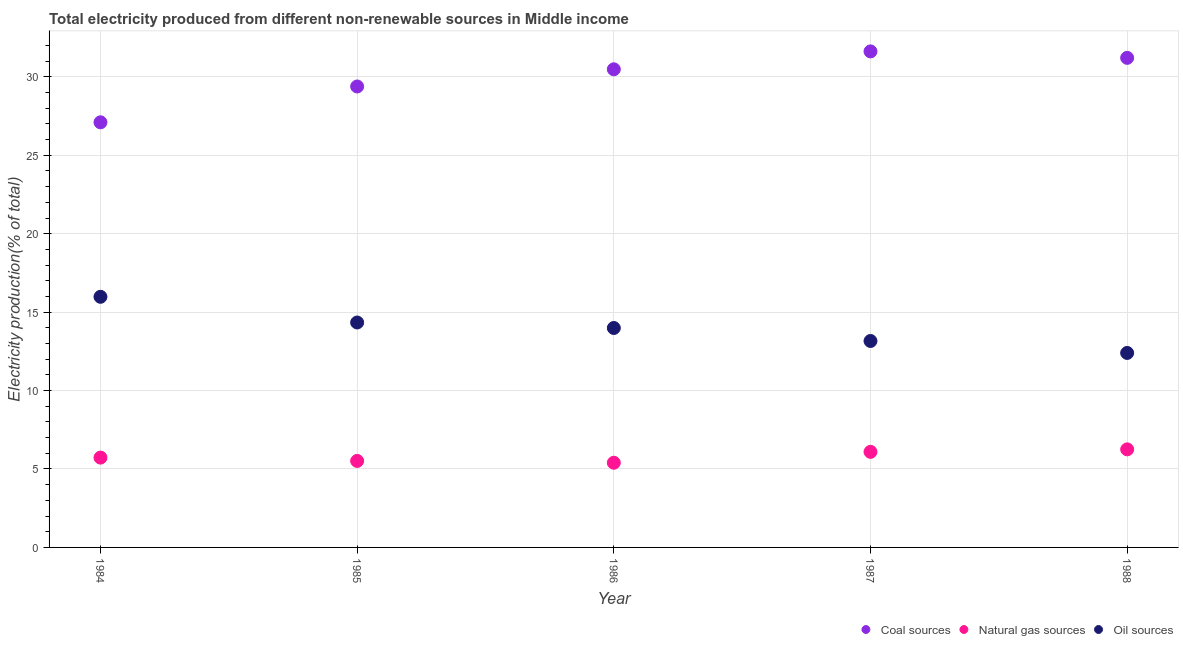Is the number of dotlines equal to the number of legend labels?
Make the answer very short. Yes. What is the percentage of electricity produced by natural gas in 1988?
Your answer should be compact. 6.25. Across all years, what is the maximum percentage of electricity produced by oil sources?
Offer a terse response. 15.98. Across all years, what is the minimum percentage of electricity produced by coal?
Keep it short and to the point. 27.1. What is the total percentage of electricity produced by natural gas in the graph?
Offer a very short reply. 28.98. What is the difference between the percentage of electricity produced by natural gas in 1986 and that in 1988?
Make the answer very short. -0.85. What is the difference between the percentage of electricity produced by natural gas in 1985 and the percentage of electricity produced by coal in 1984?
Your answer should be very brief. -21.59. What is the average percentage of electricity produced by natural gas per year?
Your answer should be compact. 5.8. In the year 1987, what is the difference between the percentage of electricity produced by natural gas and percentage of electricity produced by oil sources?
Your response must be concise. -7.07. In how many years, is the percentage of electricity produced by oil sources greater than 18 %?
Offer a very short reply. 0. What is the ratio of the percentage of electricity produced by natural gas in 1984 to that in 1985?
Provide a succinct answer. 1.04. Is the difference between the percentage of electricity produced by natural gas in 1986 and 1987 greater than the difference between the percentage of electricity produced by coal in 1986 and 1987?
Provide a succinct answer. Yes. What is the difference between the highest and the second highest percentage of electricity produced by natural gas?
Ensure brevity in your answer.  0.16. What is the difference between the highest and the lowest percentage of electricity produced by oil sources?
Make the answer very short. 3.58. In how many years, is the percentage of electricity produced by coal greater than the average percentage of electricity produced by coal taken over all years?
Keep it short and to the point. 3. How many dotlines are there?
Offer a very short reply. 3. What is the difference between two consecutive major ticks on the Y-axis?
Your answer should be compact. 5. Does the graph contain any zero values?
Your answer should be very brief. No. Where does the legend appear in the graph?
Give a very brief answer. Bottom right. How many legend labels are there?
Provide a short and direct response. 3. How are the legend labels stacked?
Offer a terse response. Horizontal. What is the title of the graph?
Ensure brevity in your answer.  Total electricity produced from different non-renewable sources in Middle income. What is the Electricity production(% of total) in Coal sources in 1984?
Ensure brevity in your answer.  27.1. What is the Electricity production(% of total) in Natural gas sources in 1984?
Make the answer very short. 5.73. What is the Electricity production(% of total) of Oil sources in 1984?
Your response must be concise. 15.98. What is the Electricity production(% of total) in Coal sources in 1985?
Keep it short and to the point. 29.39. What is the Electricity production(% of total) in Natural gas sources in 1985?
Keep it short and to the point. 5.52. What is the Electricity production(% of total) in Oil sources in 1985?
Ensure brevity in your answer.  14.34. What is the Electricity production(% of total) in Coal sources in 1986?
Your answer should be very brief. 30.48. What is the Electricity production(% of total) of Natural gas sources in 1986?
Your response must be concise. 5.4. What is the Electricity production(% of total) of Oil sources in 1986?
Offer a terse response. 13.99. What is the Electricity production(% of total) of Coal sources in 1987?
Your response must be concise. 31.62. What is the Electricity production(% of total) of Natural gas sources in 1987?
Keep it short and to the point. 6.09. What is the Electricity production(% of total) in Oil sources in 1987?
Give a very brief answer. 13.16. What is the Electricity production(% of total) in Coal sources in 1988?
Provide a short and direct response. 31.21. What is the Electricity production(% of total) of Natural gas sources in 1988?
Give a very brief answer. 6.25. What is the Electricity production(% of total) in Oil sources in 1988?
Your response must be concise. 12.4. Across all years, what is the maximum Electricity production(% of total) of Coal sources?
Ensure brevity in your answer.  31.62. Across all years, what is the maximum Electricity production(% of total) in Natural gas sources?
Ensure brevity in your answer.  6.25. Across all years, what is the maximum Electricity production(% of total) in Oil sources?
Offer a terse response. 15.98. Across all years, what is the minimum Electricity production(% of total) of Coal sources?
Your response must be concise. 27.1. Across all years, what is the minimum Electricity production(% of total) of Natural gas sources?
Your answer should be very brief. 5.4. Across all years, what is the minimum Electricity production(% of total) in Oil sources?
Offer a very short reply. 12.4. What is the total Electricity production(% of total) in Coal sources in the graph?
Give a very brief answer. 149.8. What is the total Electricity production(% of total) in Natural gas sources in the graph?
Provide a short and direct response. 28.98. What is the total Electricity production(% of total) in Oil sources in the graph?
Offer a very short reply. 69.86. What is the difference between the Electricity production(% of total) of Coal sources in 1984 and that in 1985?
Keep it short and to the point. -2.28. What is the difference between the Electricity production(% of total) of Natural gas sources in 1984 and that in 1985?
Keep it short and to the point. 0.21. What is the difference between the Electricity production(% of total) in Oil sources in 1984 and that in 1985?
Your answer should be very brief. 1.64. What is the difference between the Electricity production(% of total) in Coal sources in 1984 and that in 1986?
Keep it short and to the point. -3.38. What is the difference between the Electricity production(% of total) in Natural gas sources in 1984 and that in 1986?
Ensure brevity in your answer.  0.33. What is the difference between the Electricity production(% of total) in Oil sources in 1984 and that in 1986?
Offer a terse response. 1.99. What is the difference between the Electricity production(% of total) in Coal sources in 1984 and that in 1987?
Make the answer very short. -4.52. What is the difference between the Electricity production(% of total) in Natural gas sources in 1984 and that in 1987?
Offer a terse response. -0.37. What is the difference between the Electricity production(% of total) of Oil sources in 1984 and that in 1987?
Your response must be concise. 2.82. What is the difference between the Electricity production(% of total) in Coal sources in 1984 and that in 1988?
Offer a terse response. -4.11. What is the difference between the Electricity production(% of total) of Natural gas sources in 1984 and that in 1988?
Your response must be concise. -0.53. What is the difference between the Electricity production(% of total) of Oil sources in 1984 and that in 1988?
Make the answer very short. 3.58. What is the difference between the Electricity production(% of total) in Coal sources in 1985 and that in 1986?
Offer a very short reply. -1.09. What is the difference between the Electricity production(% of total) in Natural gas sources in 1985 and that in 1986?
Give a very brief answer. 0.12. What is the difference between the Electricity production(% of total) of Oil sources in 1985 and that in 1986?
Offer a terse response. 0.35. What is the difference between the Electricity production(% of total) in Coal sources in 1985 and that in 1987?
Offer a very short reply. -2.24. What is the difference between the Electricity production(% of total) in Natural gas sources in 1985 and that in 1987?
Provide a short and direct response. -0.58. What is the difference between the Electricity production(% of total) of Oil sources in 1985 and that in 1987?
Ensure brevity in your answer.  1.18. What is the difference between the Electricity production(% of total) of Coal sources in 1985 and that in 1988?
Make the answer very short. -1.83. What is the difference between the Electricity production(% of total) in Natural gas sources in 1985 and that in 1988?
Ensure brevity in your answer.  -0.74. What is the difference between the Electricity production(% of total) in Oil sources in 1985 and that in 1988?
Your answer should be compact. 1.94. What is the difference between the Electricity production(% of total) in Coal sources in 1986 and that in 1987?
Make the answer very short. -1.14. What is the difference between the Electricity production(% of total) in Natural gas sources in 1986 and that in 1987?
Keep it short and to the point. -0.69. What is the difference between the Electricity production(% of total) of Oil sources in 1986 and that in 1987?
Offer a very short reply. 0.83. What is the difference between the Electricity production(% of total) of Coal sources in 1986 and that in 1988?
Your answer should be very brief. -0.73. What is the difference between the Electricity production(% of total) of Natural gas sources in 1986 and that in 1988?
Your answer should be compact. -0.85. What is the difference between the Electricity production(% of total) in Oil sources in 1986 and that in 1988?
Your answer should be compact. 1.59. What is the difference between the Electricity production(% of total) of Coal sources in 1987 and that in 1988?
Your response must be concise. 0.41. What is the difference between the Electricity production(% of total) of Natural gas sources in 1987 and that in 1988?
Provide a succinct answer. -0.16. What is the difference between the Electricity production(% of total) of Oil sources in 1987 and that in 1988?
Your answer should be compact. 0.76. What is the difference between the Electricity production(% of total) in Coal sources in 1984 and the Electricity production(% of total) in Natural gas sources in 1985?
Give a very brief answer. 21.59. What is the difference between the Electricity production(% of total) in Coal sources in 1984 and the Electricity production(% of total) in Oil sources in 1985?
Offer a very short reply. 12.76. What is the difference between the Electricity production(% of total) in Natural gas sources in 1984 and the Electricity production(% of total) in Oil sources in 1985?
Keep it short and to the point. -8.61. What is the difference between the Electricity production(% of total) of Coal sources in 1984 and the Electricity production(% of total) of Natural gas sources in 1986?
Provide a succinct answer. 21.7. What is the difference between the Electricity production(% of total) in Coal sources in 1984 and the Electricity production(% of total) in Oil sources in 1986?
Your response must be concise. 13.11. What is the difference between the Electricity production(% of total) in Natural gas sources in 1984 and the Electricity production(% of total) in Oil sources in 1986?
Offer a very short reply. -8.26. What is the difference between the Electricity production(% of total) in Coal sources in 1984 and the Electricity production(% of total) in Natural gas sources in 1987?
Offer a terse response. 21.01. What is the difference between the Electricity production(% of total) of Coal sources in 1984 and the Electricity production(% of total) of Oil sources in 1987?
Keep it short and to the point. 13.94. What is the difference between the Electricity production(% of total) in Natural gas sources in 1984 and the Electricity production(% of total) in Oil sources in 1987?
Your answer should be compact. -7.43. What is the difference between the Electricity production(% of total) of Coal sources in 1984 and the Electricity production(% of total) of Natural gas sources in 1988?
Your answer should be very brief. 20.85. What is the difference between the Electricity production(% of total) in Coal sources in 1984 and the Electricity production(% of total) in Oil sources in 1988?
Offer a very short reply. 14.7. What is the difference between the Electricity production(% of total) in Natural gas sources in 1984 and the Electricity production(% of total) in Oil sources in 1988?
Offer a very short reply. -6.67. What is the difference between the Electricity production(% of total) in Coal sources in 1985 and the Electricity production(% of total) in Natural gas sources in 1986?
Provide a succinct answer. 23.99. What is the difference between the Electricity production(% of total) of Coal sources in 1985 and the Electricity production(% of total) of Oil sources in 1986?
Provide a short and direct response. 15.4. What is the difference between the Electricity production(% of total) of Natural gas sources in 1985 and the Electricity production(% of total) of Oil sources in 1986?
Your answer should be compact. -8.47. What is the difference between the Electricity production(% of total) in Coal sources in 1985 and the Electricity production(% of total) in Natural gas sources in 1987?
Your answer should be compact. 23.29. What is the difference between the Electricity production(% of total) in Coal sources in 1985 and the Electricity production(% of total) in Oil sources in 1987?
Your answer should be very brief. 16.23. What is the difference between the Electricity production(% of total) of Natural gas sources in 1985 and the Electricity production(% of total) of Oil sources in 1987?
Give a very brief answer. -7.65. What is the difference between the Electricity production(% of total) in Coal sources in 1985 and the Electricity production(% of total) in Natural gas sources in 1988?
Make the answer very short. 23.13. What is the difference between the Electricity production(% of total) of Coal sources in 1985 and the Electricity production(% of total) of Oil sources in 1988?
Ensure brevity in your answer.  16.99. What is the difference between the Electricity production(% of total) of Natural gas sources in 1985 and the Electricity production(% of total) of Oil sources in 1988?
Provide a short and direct response. -6.88. What is the difference between the Electricity production(% of total) in Coal sources in 1986 and the Electricity production(% of total) in Natural gas sources in 1987?
Provide a succinct answer. 24.39. What is the difference between the Electricity production(% of total) in Coal sources in 1986 and the Electricity production(% of total) in Oil sources in 1987?
Ensure brevity in your answer.  17.32. What is the difference between the Electricity production(% of total) in Natural gas sources in 1986 and the Electricity production(% of total) in Oil sources in 1987?
Ensure brevity in your answer.  -7.76. What is the difference between the Electricity production(% of total) of Coal sources in 1986 and the Electricity production(% of total) of Natural gas sources in 1988?
Your response must be concise. 24.23. What is the difference between the Electricity production(% of total) of Coal sources in 1986 and the Electricity production(% of total) of Oil sources in 1988?
Make the answer very short. 18.08. What is the difference between the Electricity production(% of total) of Natural gas sources in 1986 and the Electricity production(% of total) of Oil sources in 1988?
Ensure brevity in your answer.  -7. What is the difference between the Electricity production(% of total) in Coal sources in 1987 and the Electricity production(% of total) in Natural gas sources in 1988?
Offer a terse response. 25.37. What is the difference between the Electricity production(% of total) in Coal sources in 1987 and the Electricity production(% of total) in Oil sources in 1988?
Offer a very short reply. 19.22. What is the difference between the Electricity production(% of total) of Natural gas sources in 1987 and the Electricity production(% of total) of Oil sources in 1988?
Provide a succinct answer. -6.31. What is the average Electricity production(% of total) of Coal sources per year?
Provide a succinct answer. 29.96. What is the average Electricity production(% of total) in Natural gas sources per year?
Offer a terse response. 5.8. What is the average Electricity production(% of total) in Oil sources per year?
Your answer should be very brief. 13.97. In the year 1984, what is the difference between the Electricity production(% of total) of Coal sources and Electricity production(% of total) of Natural gas sources?
Keep it short and to the point. 21.38. In the year 1984, what is the difference between the Electricity production(% of total) of Coal sources and Electricity production(% of total) of Oil sources?
Your answer should be very brief. 11.12. In the year 1984, what is the difference between the Electricity production(% of total) in Natural gas sources and Electricity production(% of total) in Oil sources?
Your answer should be very brief. -10.25. In the year 1985, what is the difference between the Electricity production(% of total) of Coal sources and Electricity production(% of total) of Natural gas sources?
Offer a terse response. 23.87. In the year 1985, what is the difference between the Electricity production(% of total) in Coal sources and Electricity production(% of total) in Oil sources?
Ensure brevity in your answer.  15.05. In the year 1985, what is the difference between the Electricity production(% of total) of Natural gas sources and Electricity production(% of total) of Oil sources?
Make the answer very short. -8.82. In the year 1986, what is the difference between the Electricity production(% of total) of Coal sources and Electricity production(% of total) of Natural gas sources?
Keep it short and to the point. 25.08. In the year 1986, what is the difference between the Electricity production(% of total) of Coal sources and Electricity production(% of total) of Oil sources?
Offer a very short reply. 16.49. In the year 1986, what is the difference between the Electricity production(% of total) in Natural gas sources and Electricity production(% of total) in Oil sources?
Provide a short and direct response. -8.59. In the year 1987, what is the difference between the Electricity production(% of total) in Coal sources and Electricity production(% of total) in Natural gas sources?
Your answer should be very brief. 25.53. In the year 1987, what is the difference between the Electricity production(% of total) in Coal sources and Electricity production(% of total) in Oil sources?
Provide a short and direct response. 18.46. In the year 1987, what is the difference between the Electricity production(% of total) of Natural gas sources and Electricity production(% of total) of Oil sources?
Keep it short and to the point. -7.07. In the year 1988, what is the difference between the Electricity production(% of total) of Coal sources and Electricity production(% of total) of Natural gas sources?
Your answer should be compact. 24.96. In the year 1988, what is the difference between the Electricity production(% of total) in Coal sources and Electricity production(% of total) in Oil sources?
Give a very brief answer. 18.81. In the year 1988, what is the difference between the Electricity production(% of total) of Natural gas sources and Electricity production(% of total) of Oil sources?
Your answer should be compact. -6.15. What is the ratio of the Electricity production(% of total) of Coal sources in 1984 to that in 1985?
Your response must be concise. 0.92. What is the ratio of the Electricity production(% of total) of Natural gas sources in 1984 to that in 1985?
Make the answer very short. 1.04. What is the ratio of the Electricity production(% of total) in Oil sources in 1984 to that in 1985?
Make the answer very short. 1.11. What is the ratio of the Electricity production(% of total) of Coal sources in 1984 to that in 1986?
Provide a short and direct response. 0.89. What is the ratio of the Electricity production(% of total) in Natural gas sources in 1984 to that in 1986?
Your answer should be very brief. 1.06. What is the ratio of the Electricity production(% of total) in Oil sources in 1984 to that in 1986?
Ensure brevity in your answer.  1.14. What is the ratio of the Electricity production(% of total) in Coal sources in 1984 to that in 1987?
Your answer should be very brief. 0.86. What is the ratio of the Electricity production(% of total) in Natural gas sources in 1984 to that in 1987?
Offer a terse response. 0.94. What is the ratio of the Electricity production(% of total) in Oil sources in 1984 to that in 1987?
Provide a short and direct response. 1.21. What is the ratio of the Electricity production(% of total) in Coal sources in 1984 to that in 1988?
Your answer should be very brief. 0.87. What is the ratio of the Electricity production(% of total) of Natural gas sources in 1984 to that in 1988?
Provide a succinct answer. 0.92. What is the ratio of the Electricity production(% of total) of Oil sources in 1984 to that in 1988?
Ensure brevity in your answer.  1.29. What is the ratio of the Electricity production(% of total) of Coal sources in 1985 to that in 1986?
Provide a succinct answer. 0.96. What is the ratio of the Electricity production(% of total) in Natural gas sources in 1985 to that in 1986?
Your answer should be very brief. 1.02. What is the ratio of the Electricity production(% of total) in Oil sources in 1985 to that in 1986?
Give a very brief answer. 1.02. What is the ratio of the Electricity production(% of total) of Coal sources in 1985 to that in 1987?
Make the answer very short. 0.93. What is the ratio of the Electricity production(% of total) of Natural gas sources in 1985 to that in 1987?
Offer a terse response. 0.91. What is the ratio of the Electricity production(% of total) of Oil sources in 1985 to that in 1987?
Keep it short and to the point. 1.09. What is the ratio of the Electricity production(% of total) of Coal sources in 1985 to that in 1988?
Your answer should be very brief. 0.94. What is the ratio of the Electricity production(% of total) in Natural gas sources in 1985 to that in 1988?
Keep it short and to the point. 0.88. What is the ratio of the Electricity production(% of total) in Oil sources in 1985 to that in 1988?
Your response must be concise. 1.16. What is the ratio of the Electricity production(% of total) in Coal sources in 1986 to that in 1987?
Make the answer very short. 0.96. What is the ratio of the Electricity production(% of total) of Natural gas sources in 1986 to that in 1987?
Ensure brevity in your answer.  0.89. What is the ratio of the Electricity production(% of total) of Oil sources in 1986 to that in 1987?
Your answer should be very brief. 1.06. What is the ratio of the Electricity production(% of total) in Coal sources in 1986 to that in 1988?
Offer a terse response. 0.98. What is the ratio of the Electricity production(% of total) of Natural gas sources in 1986 to that in 1988?
Make the answer very short. 0.86. What is the ratio of the Electricity production(% of total) in Oil sources in 1986 to that in 1988?
Make the answer very short. 1.13. What is the ratio of the Electricity production(% of total) of Coal sources in 1987 to that in 1988?
Ensure brevity in your answer.  1.01. What is the ratio of the Electricity production(% of total) of Natural gas sources in 1987 to that in 1988?
Offer a very short reply. 0.97. What is the ratio of the Electricity production(% of total) of Oil sources in 1987 to that in 1988?
Make the answer very short. 1.06. What is the difference between the highest and the second highest Electricity production(% of total) of Coal sources?
Ensure brevity in your answer.  0.41. What is the difference between the highest and the second highest Electricity production(% of total) of Natural gas sources?
Your response must be concise. 0.16. What is the difference between the highest and the second highest Electricity production(% of total) in Oil sources?
Ensure brevity in your answer.  1.64. What is the difference between the highest and the lowest Electricity production(% of total) in Coal sources?
Provide a succinct answer. 4.52. What is the difference between the highest and the lowest Electricity production(% of total) in Natural gas sources?
Give a very brief answer. 0.85. What is the difference between the highest and the lowest Electricity production(% of total) of Oil sources?
Ensure brevity in your answer.  3.58. 